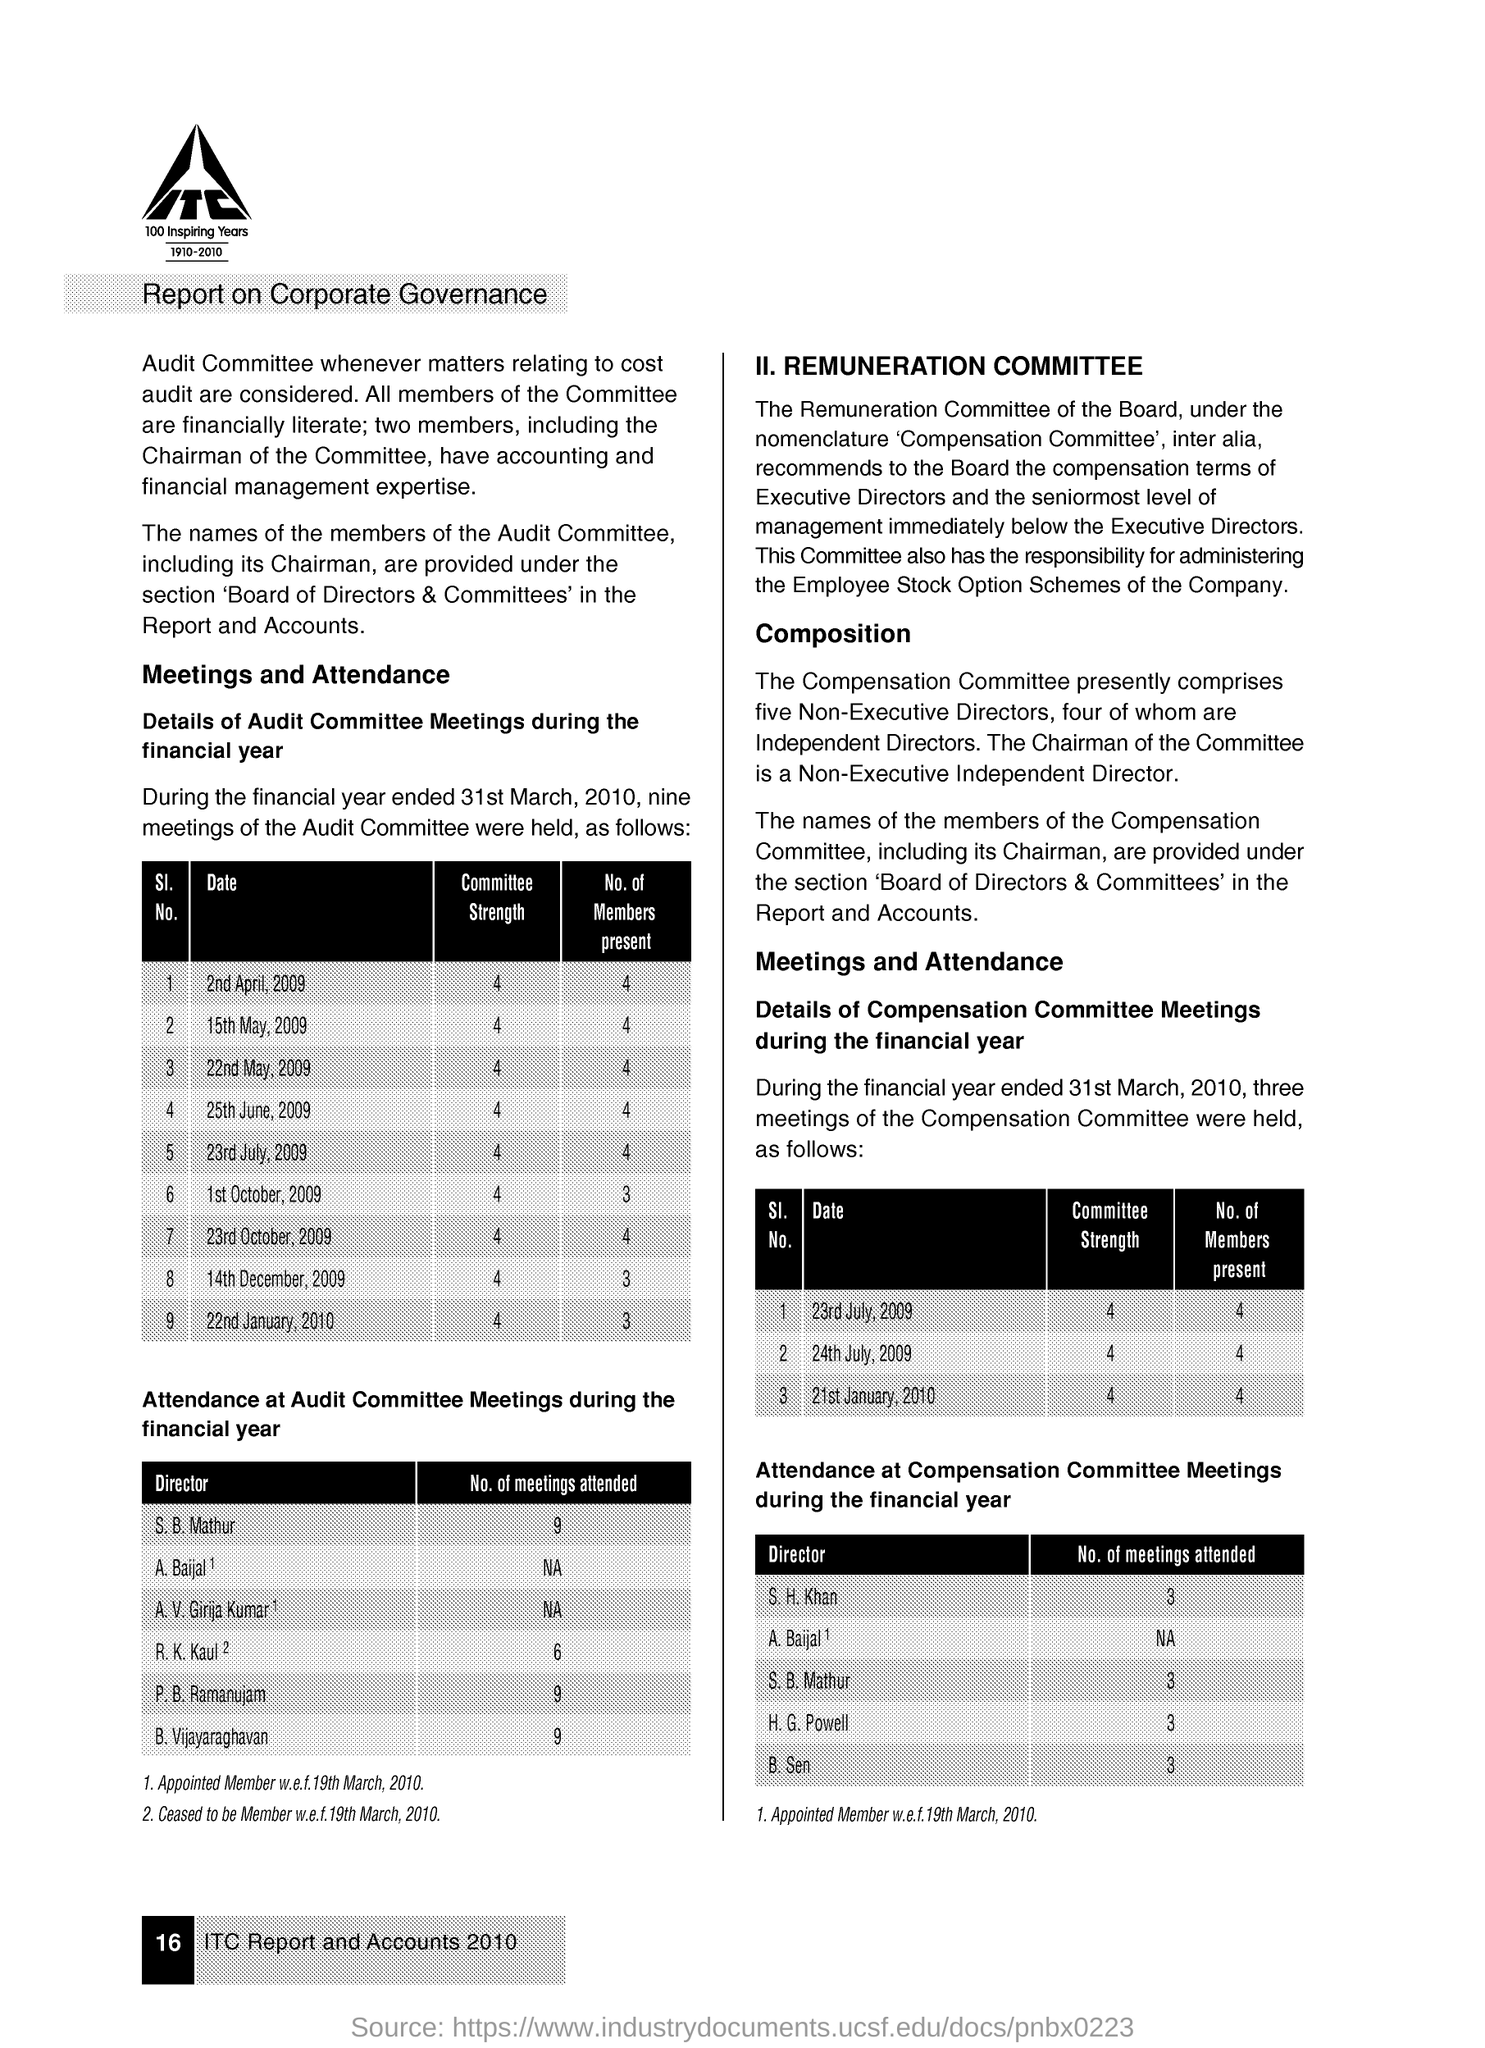Specify some key components in this picture. The report is relevant to the topic of corporate governance. 